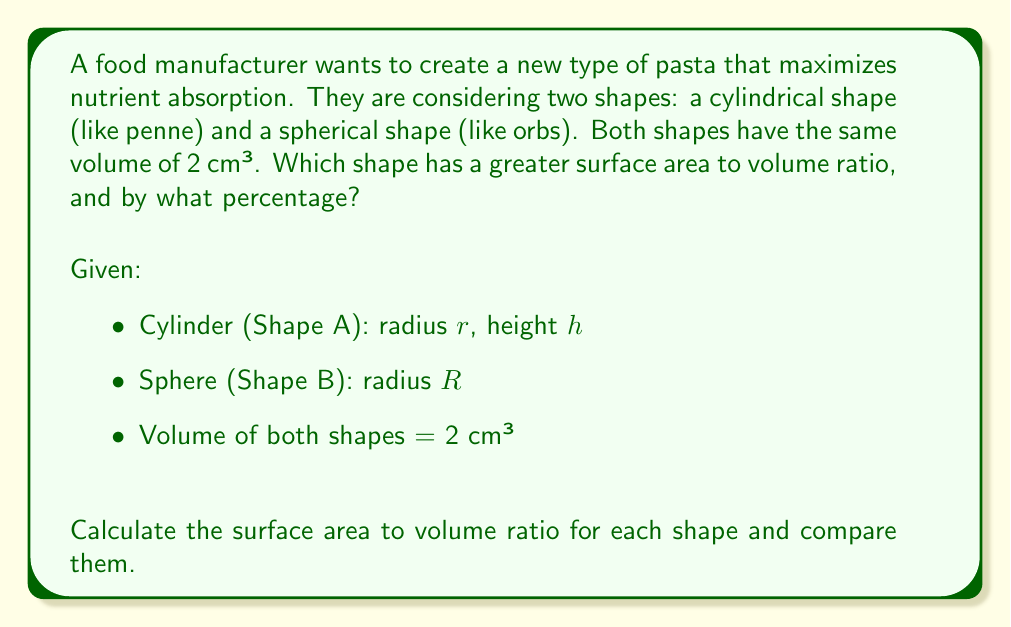Show me your answer to this math problem. Let's approach this step-by-step:

1) For the cylinder (Shape A):
   Volume: $V_A = \pi r^2 h = 2$ cm³
   Surface Area: $SA_A = 2\pi r^2 + 2\pi rh$
   
   We need to express $h$ in terms of $r$:
   $\pi r^2 h = 2$
   $h = \frac{2}{\pi r^2}$
   
   Surface Area: $SA_A = 2\pi r^2 + 2\pi r(\frac{2}{\pi r^2}) = 2\pi r^2 + \frac{4}{r}$
   
   Surface Area to Volume ratio: $\frac{SA_A}{V_A} = \frac{2\pi r^2 + \frac{4}{r}}{2} = \pi r + \frac{2}{r^2}$

2) For the sphere (Shape B):
   Volume: $V_B = \frac{4}{3}\pi R^3 = 2$ cm³
   
   Solving for $R$: $R = \sqrt[3]{\frac{3}{2\pi}} \approx 0.7937$ cm
   
   Surface Area: $SA_B = 4\pi R^2 = 4\pi (\frac{3}{2\pi})^{\frac{2}{3}} \approx 7.9168$ cm²
   
   Surface Area to Volume ratio: $\frac{SA_B}{V_B} = \frac{7.9168}{2} \approx 3.9584$ cm^-1

3) For the cylinder, we need to find the optimal $r$ that maximizes the surface area to volume ratio:

   $\frac{d}{dr}(\pi r + \frac{2}{r^2}) = \pi - \frac{4}{r^3} = 0$
   
   Solving this: $r = \sqrt[3]{\frac{4}{\pi}} \approx 0.9207$ cm
   
   $h = \frac{2}{\pi r^2} \approx 0.7465$ cm
   
   Maximum $\frac{SA_A}{V_A} = \pi r + \frac{2}{r^2} \approx 4.8442$ cm^-1

4) Comparing the ratios:
   Cylinder: 4.8442 cm^-1
   Sphere: 3.9584 cm^-1
   
   Percentage difference = $\frac{4.8442 - 3.9584}{3.9584} \times 100\% \approx 22.38\%$
Answer: The cylindrical shape has a greater surface area to volume ratio, exceeding that of the spherical shape by approximately 22.38%. 